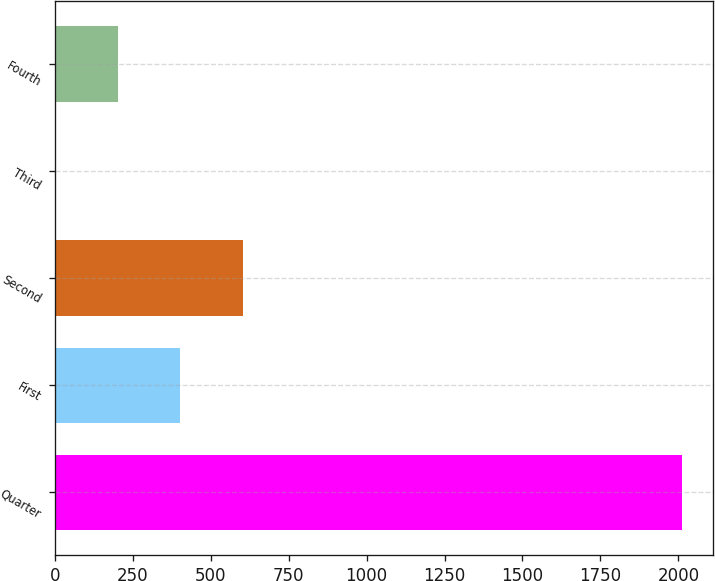<chart> <loc_0><loc_0><loc_500><loc_500><bar_chart><fcel>Quarter<fcel>First<fcel>Second<fcel>Third<fcel>Fourth<nl><fcel>2012<fcel>402.56<fcel>603.74<fcel>0.2<fcel>201.38<nl></chart> 